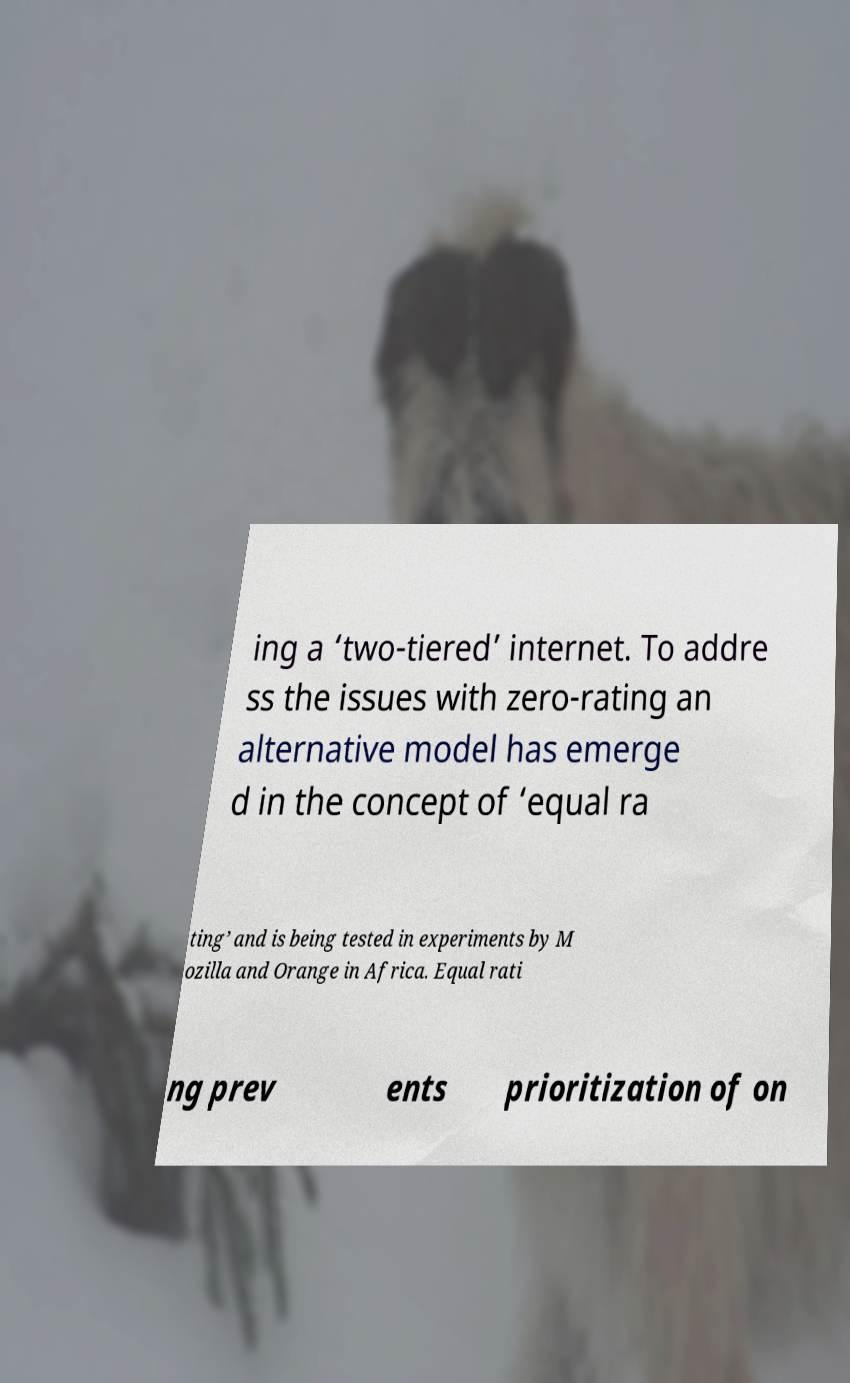Could you assist in decoding the text presented in this image and type it out clearly? ing a ‘two-tiered’ internet. To addre ss the issues with zero-rating an alternative model has emerge d in the concept of ‘equal ra ting’ and is being tested in experiments by M ozilla and Orange in Africa. Equal rati ng prev ents prioritization of on 